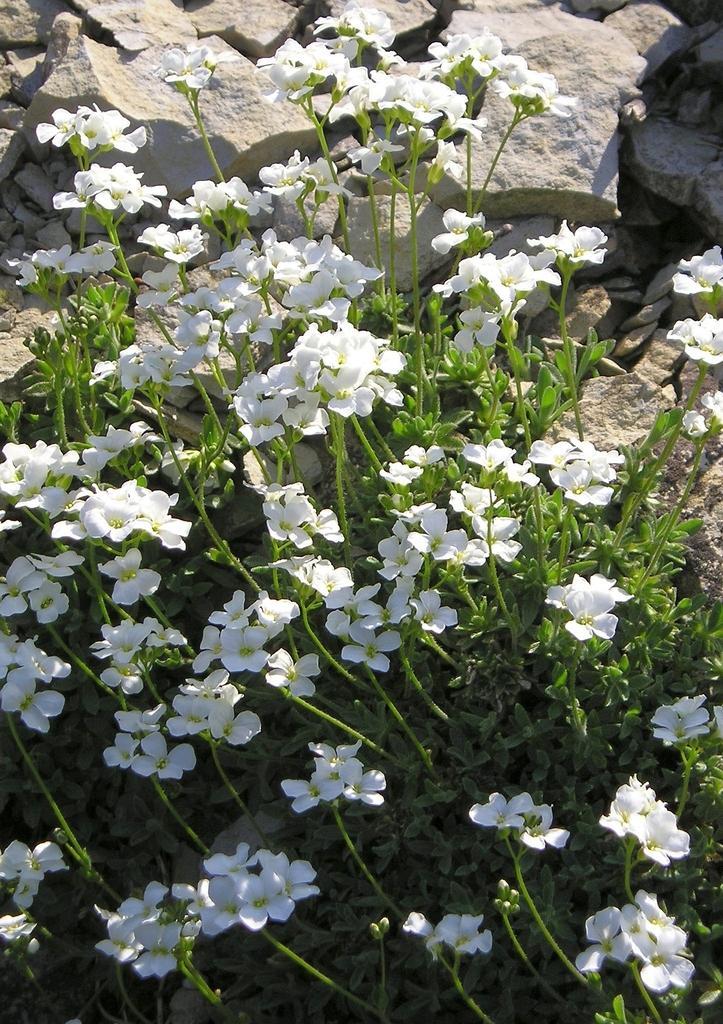Please provide a concise description of this image. In the center of the image there are plants and we can see flowers to it. In the background there are rocks. 